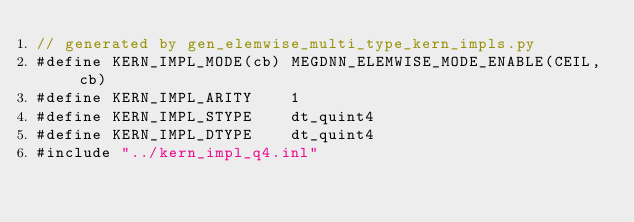<code> <loc_0><loc_0><loc_500><loc_500><_Cuda_>// generated by gen_elemwise_multi_type_kern_impls.py
#define KERN_IMPL_MODE(cb) MEGDNN_ELEMWISE_MODE_ENABLE(CEIL, cb)
#define KERN_IMPL_ARITY    1
#define KERN_IMPL_STYPE    dt_quint4
#define KERN_IMPL_DTYPE    dt_quint4
#include "../kern_impl_q4.inl"
</code> 